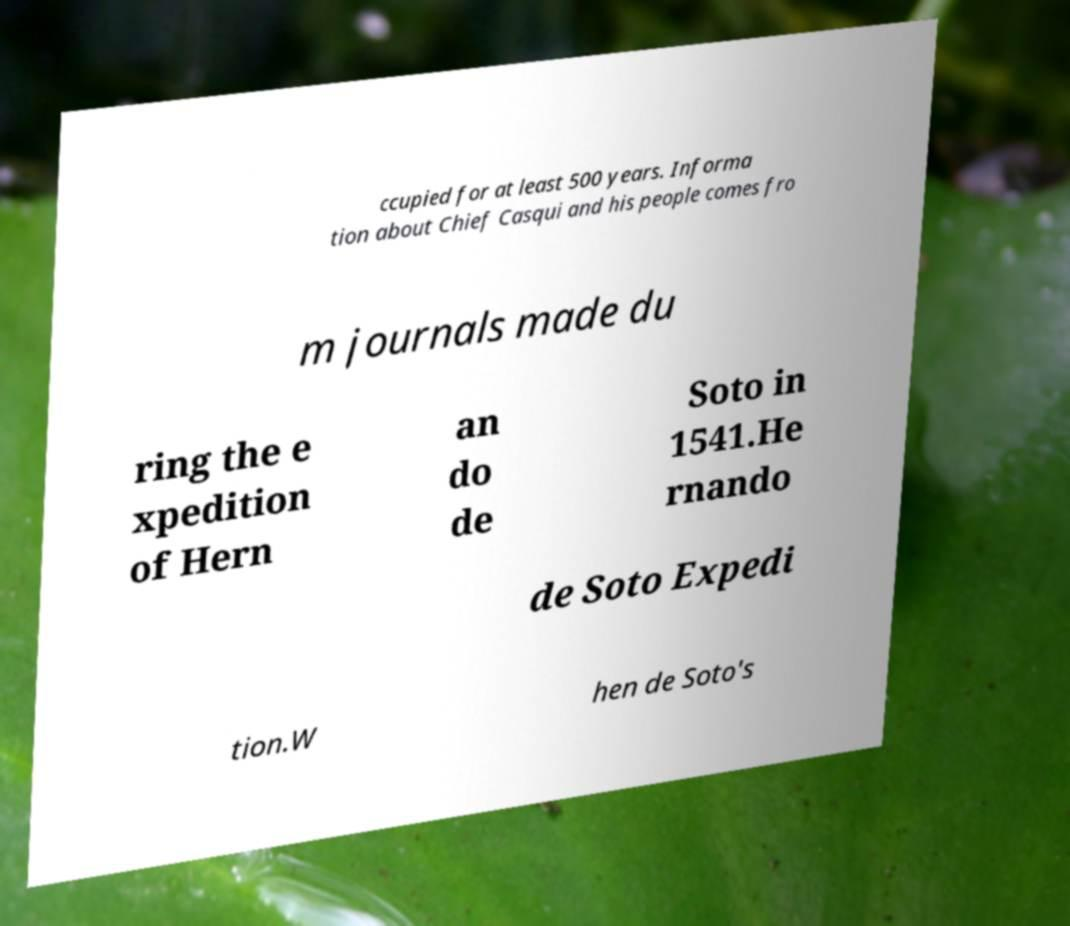Please identify and transcribe the text found in this image. ccupied for at least 500 years. Informa tion about Chief Casqui and his people comes fro m journals made du ring the e xpedition of Hern an do de Soto in 1541.He rnando de Soto Expedi tion.W hen de Soto's 